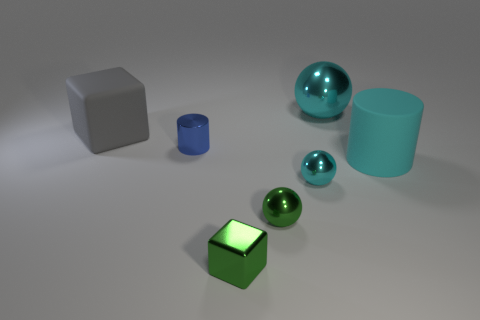Subtract all tiny balls. How many balls are left? 1 Subtract all purple cylinders. How many cyan spheres are left? 2 Add 3 cyan cylinders. How many objects exist? 10 Subtract all balls. How many objects are left? 4 Subtract all blue balls. Subtract all yellow blocks. How many balls are left? 3 Add 6 blue things. How many blue things exist? 7 Subtract 1 green cubes. How many objects are left? 6 Subtract all blue cylinders. Subtract all tiny green spheres. How many objects are left? 5 Add 4 shiny balls. How many shiny balls are left? 7 